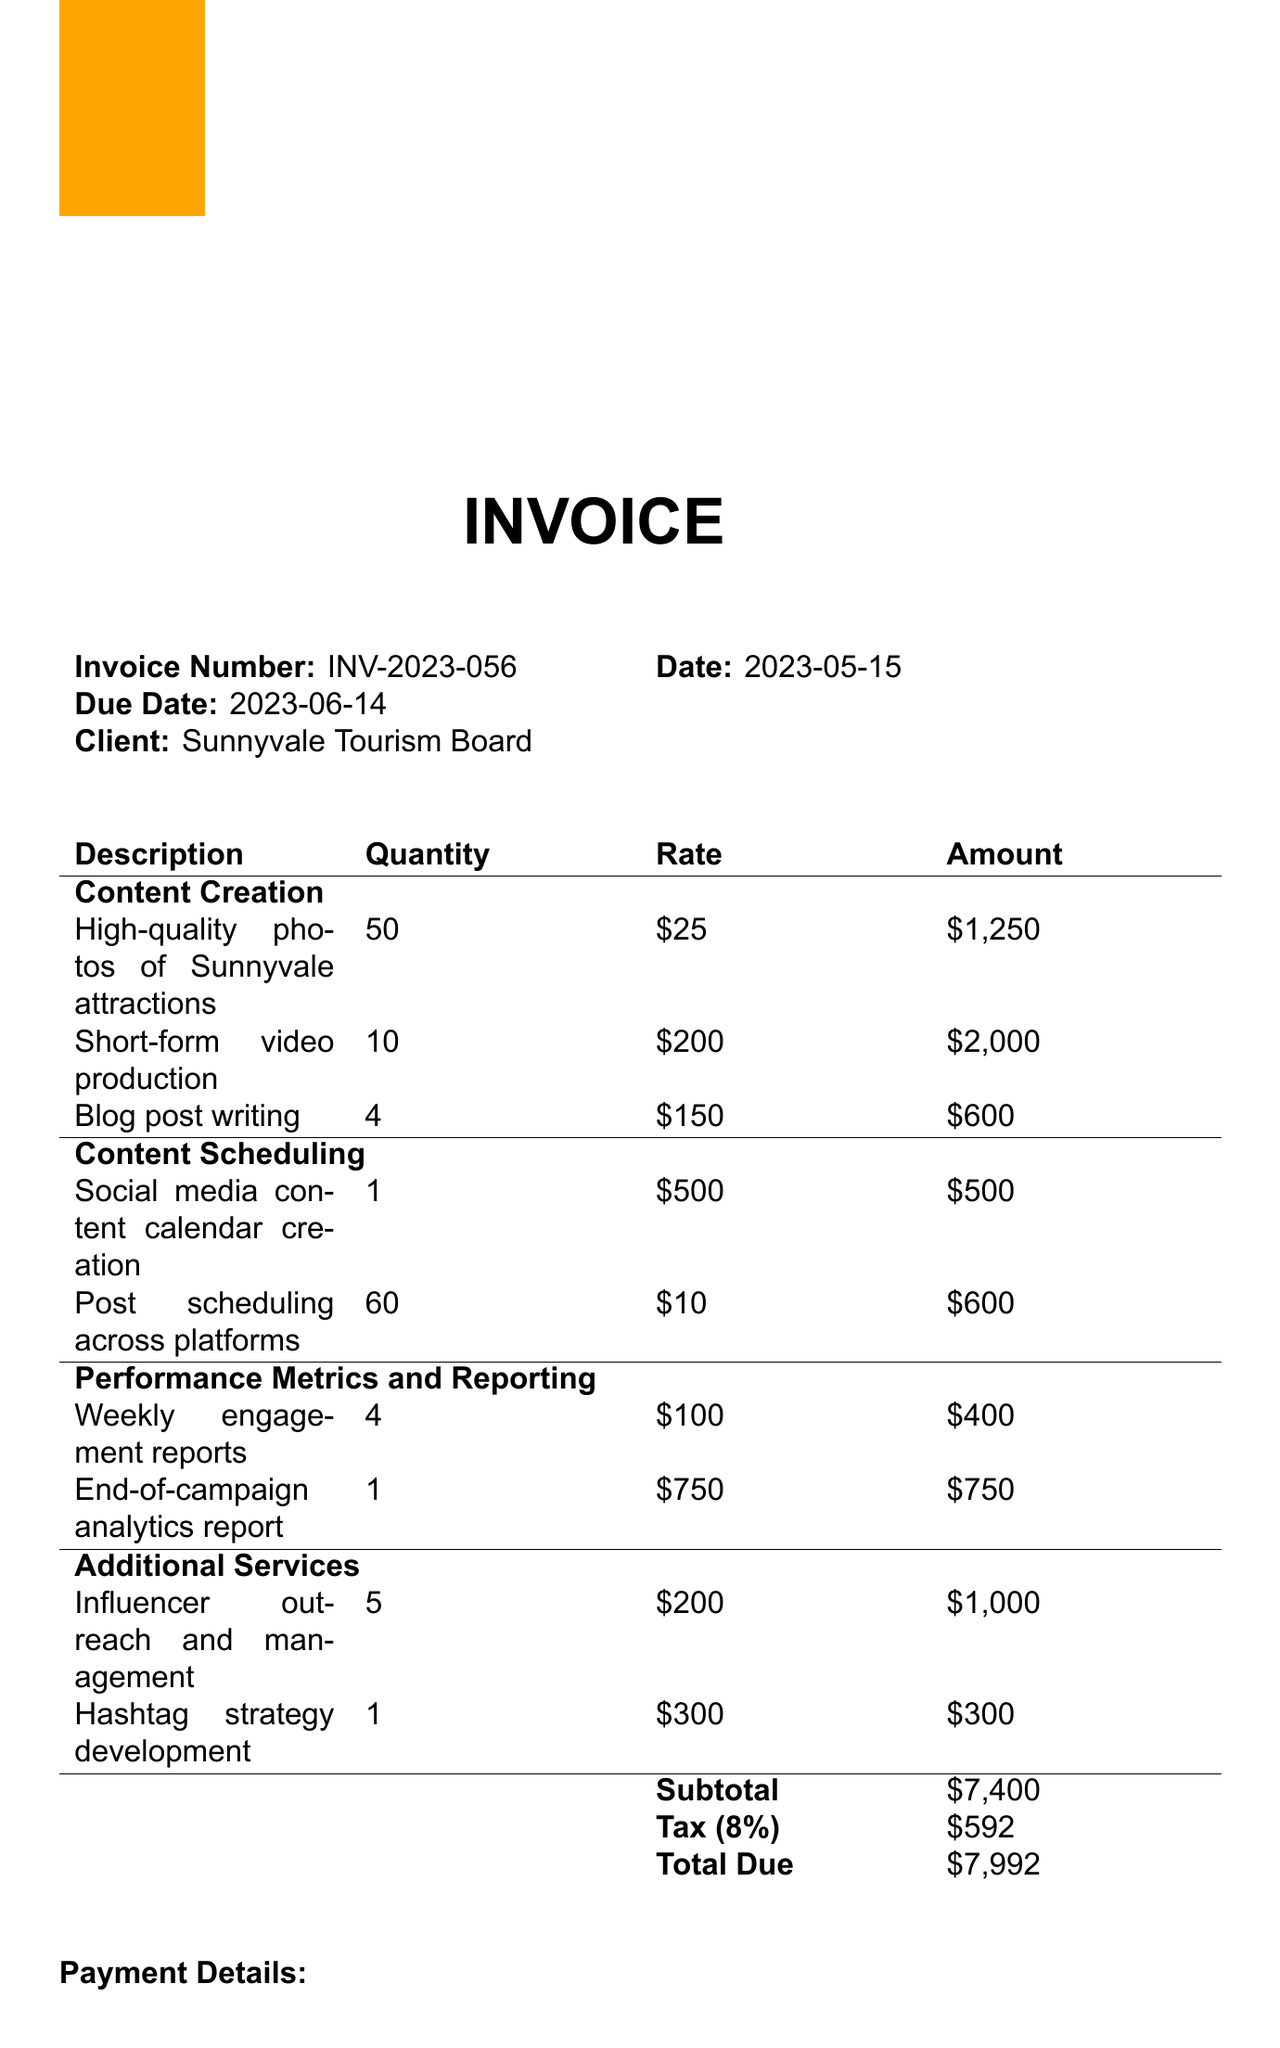what is the invoice number? The invoice number is listed at the top of the document for reference.
Answer: INV-2023-056 who is the service provider? The service provider is mentioned clearly as part of the client information on the invoice.
Answer: TravelBuzz Digital Marketing what is the total due amount? The total due amount is calculated by adding the subtotal and tax, which is given in the payment details.
Answer: $7,992 what are the campaign platforms? The platforms used for the campaign are listed in the campaign details section.
Answer: Instagram, Facebook, Twitter, TikTok how many high-quality photos were created? The document specifies the quantity of high-quality photos created under the content creation section.
Answer: 50 what is the engagement rate achieved? The engagement rate is highlighted as part of the performance metrics in the document.
Answer: 4.8% how long was the campaign duration? The campaign duration is stated in the campaign details section, which provides specific start and end dates.
Answer: 30 days (April 15 - May 14, 2023) what is the payment method? The payment method is outlined clearly under the payment details section of the document.
Answer: Bank Transfer what are the terms for late payments? The terms for late payments are specified in the terms and conditions section of the invoice.
Answer: 5% monthly interest charge 